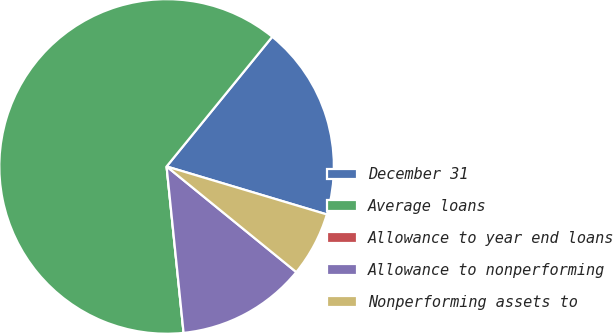Convert chart. <chart><loc_0><loc_0><loc_500><loc_500><pie_chart><fcel>December 31<fcel>Average loans<fcel>Allowance to year end loans<fcel>Allowance to nonperforming<fcel>Nonperforming assets to<nl><fcel>18.75%<fcel>62.5%<fcel>0.0%<fcel>12.5%<fcel>6.25%<nl></chart> 